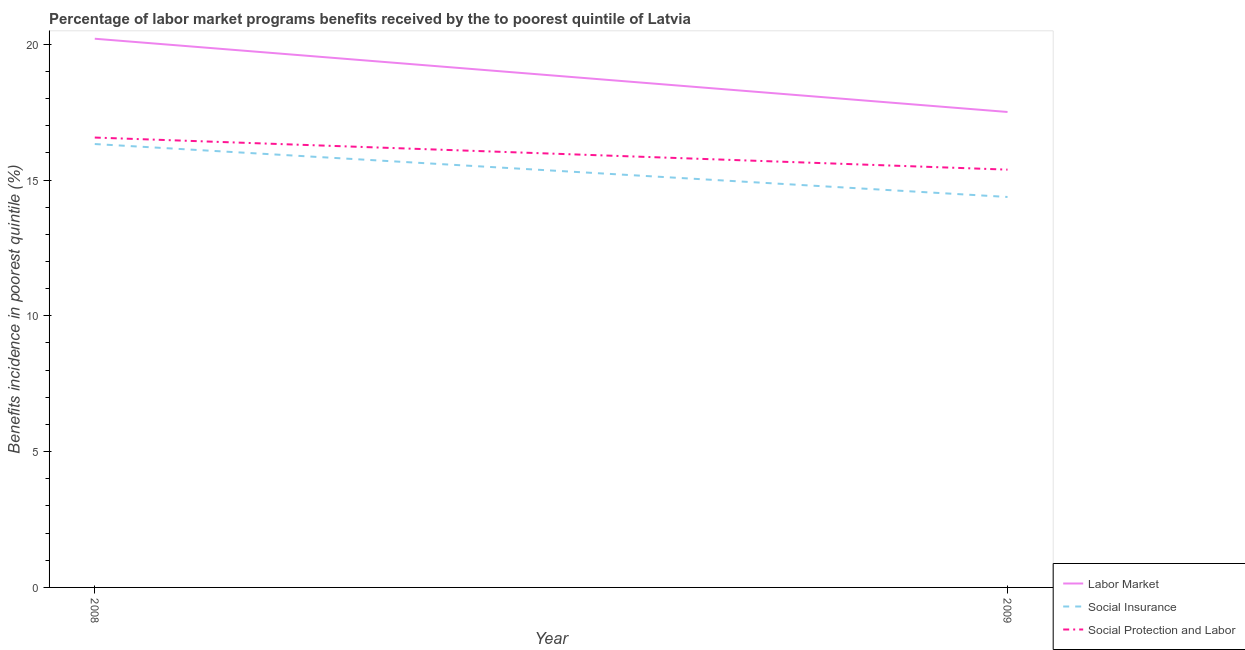Is the number of lines equal to the number of legend labels?
Offer a terse response. Yes. What is the percentage of benefits received due to social insurance programs in 2008?
Ensure brevity in your answer.  16.32. Across all years, what is the maximum percentage of benefits received due to social insurance programs?
Your answer should be very brief. 16.32. Across all years, what is the minimum percentage of benefits received due to social protection programs?
Give a very brief answer. 15.38. In which year was the percentage of benefits received due to social protection programs maximum?
Your answer should be compact. 2008. In which year was the percentage of benefits received due to social insurance programs minimum?
Keep it short and to the point. 2009. What is the total percentage of benefits received due to labor market programs in the graph?
Provide a short and direct response. 37.71. What is the difference between the percentage of benefits received due to social insurance programs in 2008 and that in 2009?
Ensure brevity in your answer.  1.95. What is the difference between the percentage of benefits received due to social protection programs in 2008 and the percentage of benefits received due to labor market programs in 2009?
Offer a very short reply. -0.94. What is the average percentage of benefits received due to social insurance programs per year?
Give a very brief answer. 15.35. In the year 2008, what is the difference between the percentage of benefits received due to social protection programs and percentage of benefits received due to labor market programs?
Keep it short and to the point. -3.64. In how many years, is the percentage of benefits received due to social insurance programs greater than 7 %?
Provide a short and direct response. 2. What is the ratio of the percentage of benefits received due to social protection programs in 2008 to that in 2009?
Provide a succinct answer. 1.08. Is the percentage of benefits received due to social insurance programs in 2008 less than that in 2009?
Make the answer very short. No. In how many years, is the percentage of benefits received due to social insurance programs greater than the average percentage of benefits received due to social insurance programs taken over all years?
Offer a very short reply. 1. Is the percentage of benefits received due to social insurance programs strictly greater than the percentage of benefits received due to social protection programs over the years?
Ensure brevity in your answer.  No. How many lines are there?
Offer a terse response. 3. What is the difference between two consecutive major ticks on the Y-axis?
Provide a succinct answer. 5. Are the values on the major ticks of Y-axis written in scientific E-notation?
Make the answer very short. No. Does the graph contain any zero values?
Give a very brief answer. No. Does the graph contain grids?
Offer a very short reply. No. How many legend labels are there?
Your answer should be compact. 3. How are the legend labels stacked?
Your answer should be compact. Vertical. What is the title of the graph?
Your response must be concise. Percentage of labor market programs benefits received by the to poorest quintile of Latvia. Does "Resident buildings and public services" appear as one of the legend labels in the graph?
Make the answer very short. No. What is the label or title of the Y-axis?
Make the answer very short. Benefits incidence in poorest quintile (%). What is the Benefits incidence in poorest quintile (%) in Labor Market in 2008?
Ensure brevity in your answer.  20.2. What is the Benefits incidence in poorest quintile (%) of Social Insurance in 2008?
Keep it short and to the point. 16.32. What is the Benefits incidence in poorest quintile (%) in Social Protection and Labor in 2008?
Your answer should be compact. 16.56. What is the Benefits incidence in poorest quintile (%) of Labor Market in 2009?
Provide a short and direct response. 17.5. What is the Benefits incidence in poorest quintile (%) in Social Insurance in 2009?
Provide a succinct answer. 14.38. What is the Benefits incidence in poorest quintile (%) of Social Protection and Labor in 2009?
Offer a very short reply. 15.38. Across all years, what is the maximum Benefits incidence in poorest quintile (%) in Labor Market?
Provide a short and direct response. 20.2. Across all years, what is the maximum Benefits incidence in poorest quintile (%) of Social Insurance?
Your answer should be compact. 16.32. Across all years, what is the maximum Benefits incidence in poorest quintile (%) of Social Protection and Labor?
Keep it short and to the point. 16.56. Across all years, what is the minimum Benefits incidence in poorest quintile (%) of Labor Market?
Provide a short and direct response. 17.5. Across all years, what is the minimum Benefits incidence in poorest quintile (%) of Social Insurance?
Your answer should be compact. 14.38. Across all years, what is the minimum Benefits incidence in poorest quintile (%) of Social Protection and Labor?
Ensure brevity in your answer.  15.38. What is the total Benefits incidence in poorest quintile (%) in Labor Market in the graph?
Make the answer very short. 37.71. What is the total Benefits incidence in poorest quintile (%) in Social Insurance in the graph?
Ensure brevity in your answer.  30.7. What is the total Benefits incidence in poorest quintile (%) of Social Protection and Labor in the graph?
Make the answer very short. 31.94. What is the difference between the Benefits incidence in poorest quintile (%) of Labor Market in 2008 and that in 2009?
Offer a terse response. 2.7. What is the difference between the Benefits incidence in poorest quintile (%) of Social Insurance in 2008 and that in 2009?
Keep it short and to the point. 1.95. What is the difference between the Benefits incidence in poorest quintile (%) of Social Protection and Labor in 2008 and that in 2009?
Your response must be concise. 1.18. What is the difference between the Benefits incidence in poorest quintile (%) in Labor Market in 2008 and the Benefits incidence in poorest quintile (%) in Social Insurance in 2009?
Offer a very short reply. 5.83. What is the difference between the Benefits incidence in poorest quintile (%) of Labor Market in 2008 and the Benefits incidence in poorest quintile (%) of Social Protection and Labor in 2009?
Ensure brevity in your answer.  4.82. What is the difference between the Benefits incidence in poorest quintile (%) of Social Insurance in 2008 and the Benefits incidence in poorest quintile (%) of Social Protection and Labor in 2009?
Give a very brief answer. 0.94. What is the average Benefits incidence in poorest quintile (%) of Labor Market per year?
Give a very brief answer. 18.85. What is the average Benefits incidence in poorest quintile (%) in Social Insurance per year?
Your answer should be very brief. 15.35. What is the average Benefits incidence in poorest quintile (%) in Social Protection and Labor per year?
Your answer should be very brief. 15.97. In the year 2008, what is the difference between the Benefits incidence in poorest quintile (%) in Labor Market and Benefits incidence in poorest quintile (%) in Social Insurance?
Give a very brief answer. 3.88. In the year 2008, what is the difference between the Benefits incidence in poorest quintile (%) of Labor Market and Benefits incidence in poorest quintile (%) of Social Protection and Labor?
Make the answer very short. 3.64. In the year 2008, what is the difference between the Benefits incidence in poorest quintile (%) in Social Insurance and Benefits incidence in poorest quintile (%) in Social Protection and Labor?
Provide a short and direct response. -0.24. In the year 2009, what is the difference between the Benefits incidence in poorest quintile (%) of Labor Market and Benefits incidence in poorest quintile (%) of Social Insurance?
Your answer should be very brief. 3.13. In the year 2009, what is the difference between the Benefits incidence in poorest quintile (%) of Labor Market and Benefits incidence in poorest quintile (%) of Social Protection and Labor?
Keep it short and to the point. 2.12. In the year 2009, what is the difference between the Benefits incidence in poorest quintile (%) of Social Insurance and Benefits incidence in poorest quintile (%) of Social Protection and Labor?
Offer a very short reply. -1.01. What is the ratio of the Benefits incidence in poorest quintile (%) of Labor Market in 2008 to that in 2009?
Make the answer very short. 1.15. What is the ratio of the Benefits incidence in poorest quintile (%) of Social Insurance in 2008 to that in 2009?
Ensure brevity in your answer.  1.14. What is the ratio of the Benefits incidence in poorest quintile (%) of Social Protection and Labor in 2008 to that in 2009?
Give a very brief answer. 1.08. What is the difference between the highest and the second highest Benefits incidence in poorest quintile (%) in Labor Market?
Make the answer very short. 2.7. What is the difference between the highest and the second highest Benefits incidence in poorest quintile (%) in Social Insurance?
Your answer should be very brief. 1.95. What is the difference between the highest and the second highest Benefits incidence in poorest quintile (%) of Social Protection and Labor?
Your answer should be very brief. 1.18. What is the difference between the highest and the lowest Benefits incidence in poorest quintile (%) in Labor Market?
Provide a succinct answer. 2.7. What is the difference between the highest and the lowest Benefits incidence in poorest quintile (%) of Social Insurance?
Keep it short and to the point. 1.95. What is the difference between the highest and the lowest Benefits incidence in poorest quintile (%) of Social Protection and Labor?
Your answer should be compact. 1.18. 